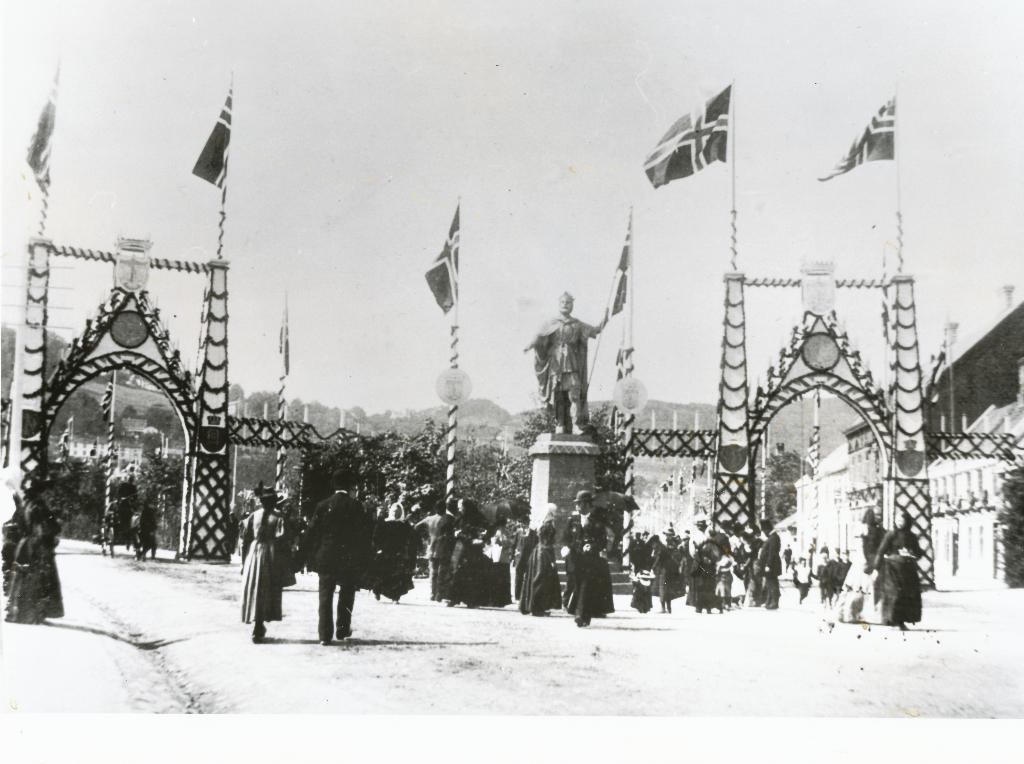Could you give a brief overview of what you see in this image? In this picture there is a poster in the center of the image, in which there is a statue in the center of the image. 